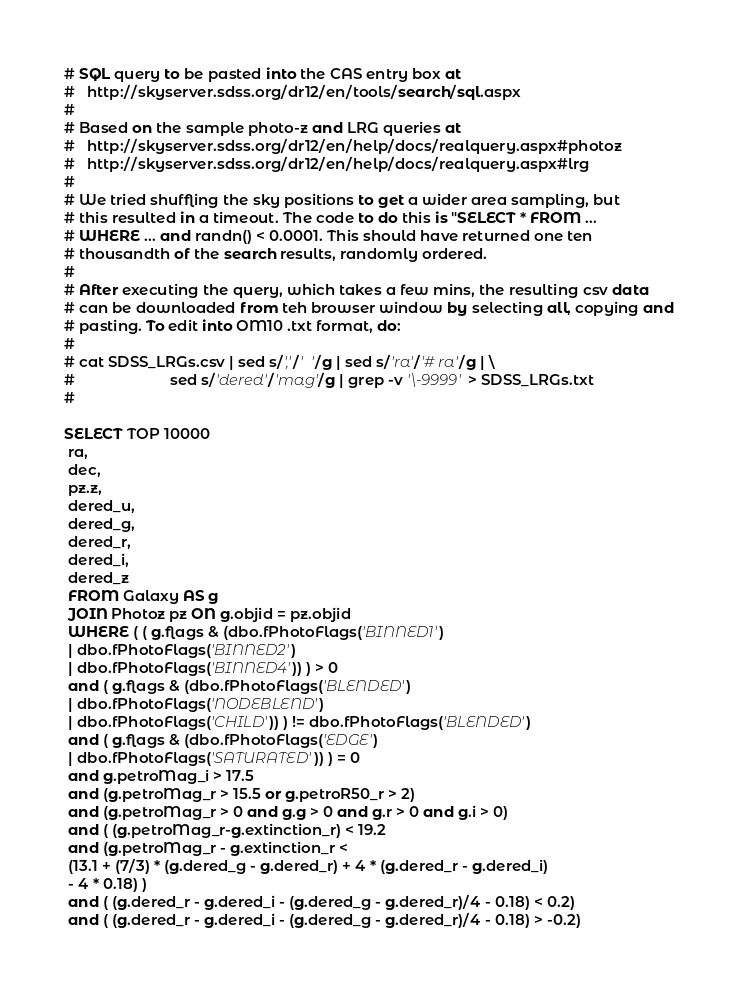Convert code to text. <code><loc_0><loc_0><loc_500><loc_500><_SQL_># SQL query to be pasted into the CAS entry box at
#   http://skyserver.sdss.org/dr12/en/tools/search/sql.aspx
#
# Based on the sample photo-z and LRG queries at 
#   http://skyserver.sdss.org/dr12/en/help/docs/realquery.aspx#photoz
#   http://skyserver.sdss.org/dr12/en/help/docs/realquery.aspx#lrg
#  
# We tried shuffling the sky positions to get a wider area sampling, but 
# this resulted in a timeout. The code to do this is "SELECT * FROM ... 
# WHERE ... and randn() < 0.0001. This should have returned one ten 
# thousandth of the search results, randomly ordered.
# 
# After executing the query, which takes a few mins, the resulting csv data
# can be downloaded from teh browser window by selecting all, copying and 
# pasting. To edit into OM10 .txt format, do:
# 
# cat SDSS_LRGs.csv | sed s/','/'  '/g | sed s/'ra'/'# ra'/g | \
#                       sed s/'dered'/'mag'/g | grep -v '\-9999' > SDSS_LRGs.txt
#

SELECT TOP 10000
 ra, 
 dec,
 pz.z,
 dered_u,
 dered_g,
 dered_r,
 dered_i,
 dered_z
 FROM Galaxy AS g
 JOIN Photoz pz ON g.objid = pz.objid
 WHERE ( ( g.flags & (dbo.fPhotoFlags('BINNED1') 
 | dbo.fPhotoFlags('BINNED2') 
 | dbo.fPhotoFlags('BINNED4')) ) > 0 
 and ( g.flags & (dbo.fPhotoFlags('BLENDED') 
 | dbo.fPhotoFlags('NODEBLEND') 
 | dbo.fPhotoFlags('CHILD')) ) != dbo.fPhotoFlags('BLENDED') 
 and ( g.flags & (dbo.fPhotoFlags('EDGE') 
 | dbo.fPhotoFlags('SATURATED')) ) = 0 
 and g.petroMag_i > 17.5 
 and (g.petroMag_r > 15.5 or g.petroR50_r > 2) 
 and (g.petroMag_r > 0 and g.g > 0 and g.r > 0 and g.i > 0) 
 and ( (g.petroMag_r-g.extinction_r) < 19.2 
 and (g.petroMag_r - g.extinction_r < 
 (13.1 + (7/3) * (g.dered_g - g.dered_r) + 4 * (g.dered_r - g.dered_i) 
 - 4 * 0.18) ) 
 and ( (g.dered_r - g.dered_i - (g.dered_g - g.dered_r)/4 - 0.18) < 0.2) 
 and ( (g.dered_r - g.dered_i - (g.dered_g - g.dered_r)/4 - 0.18) > -0.2) </code> 